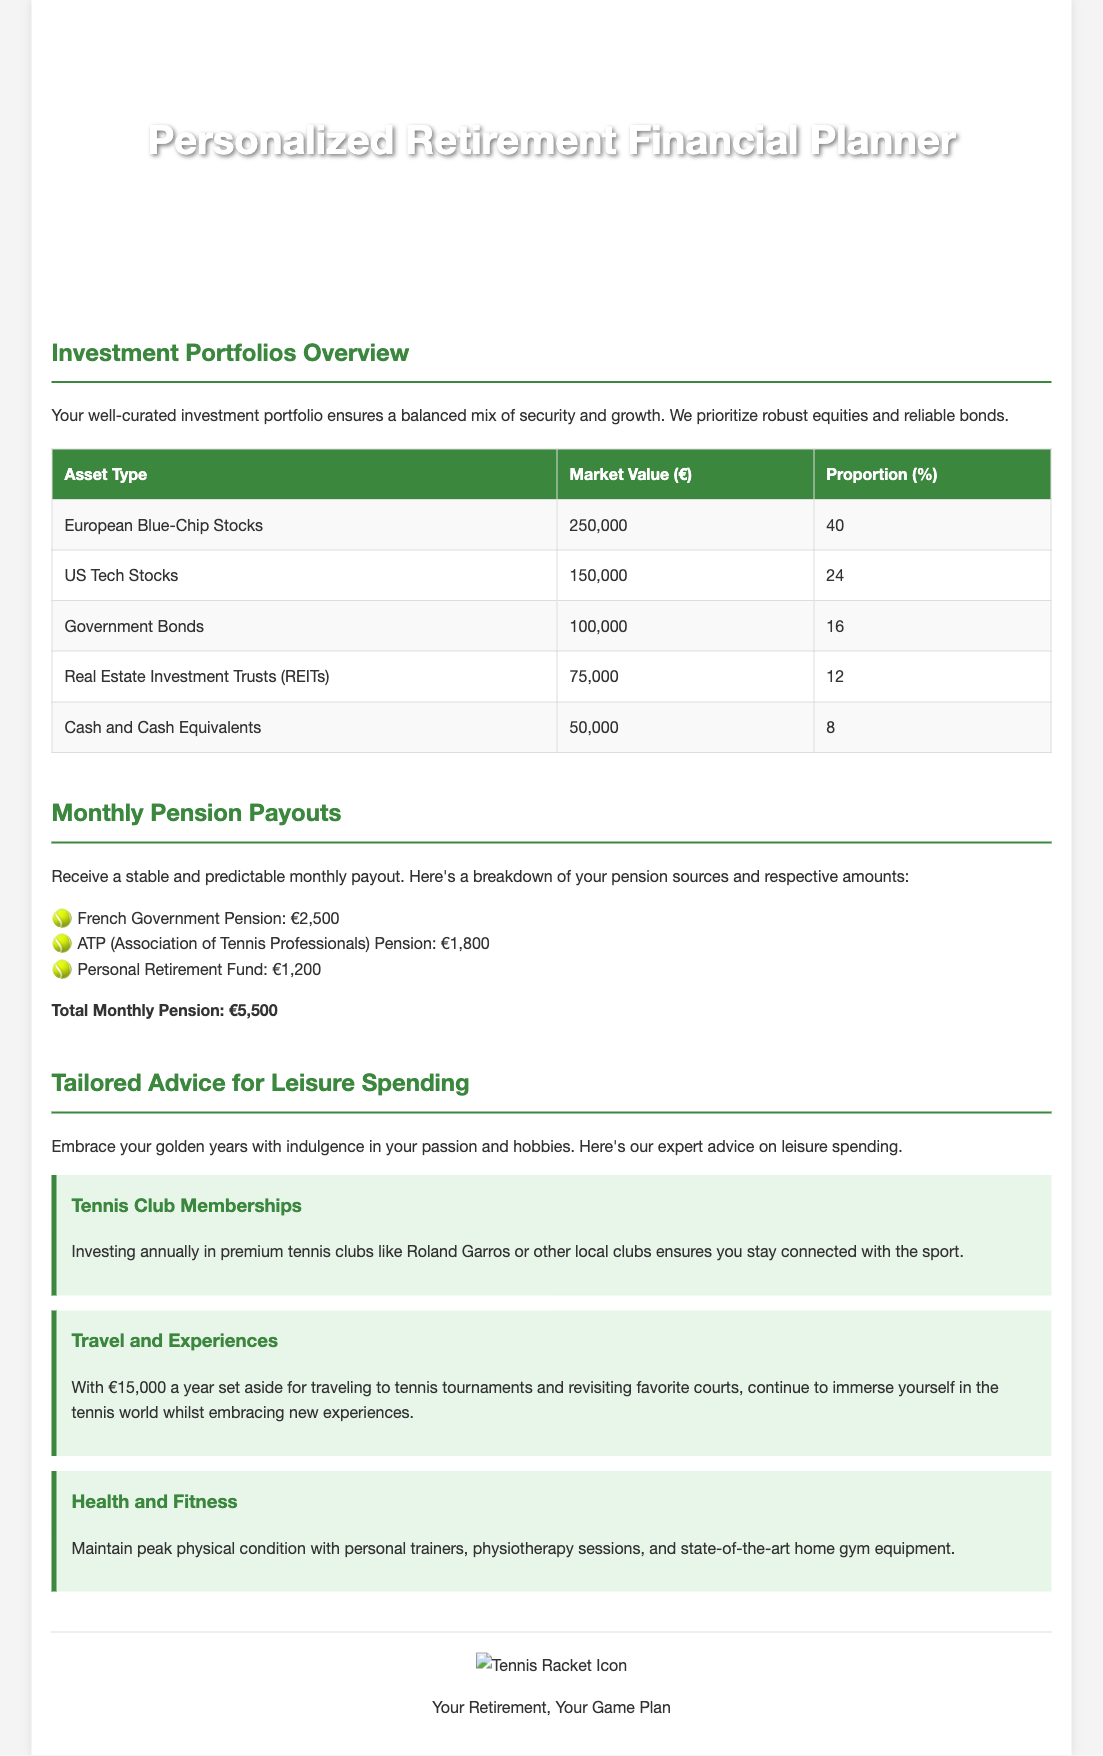what is the title of the document? The title provides an overview of the document's purpose, specifically designed for retired professional French tennis players.
Answer: Personalized Retirement Financial Planner for Retired Professional French Tennis Player how much is the total monthly pension? The total monthly pension is a sum calculated from individual pension sources listed in the document.
Answer: €5,500 what is the market value of European Blue-Chip Stocks? The market value of European Blue-Chip Stocks is specified in the investment portfolios overview table.
Answer: €250,000 which type of advice is given for leisure spending? The document provides tailored advice in three specific areas related to leisure spending.
Answer: Tennis Club Memberships, Travel and Experiences, Health and Fitness what percentage of the portfolio is allocated to Government Bonds? This percentage is listed in the investment portfolios overview section of the document.
Answer: 16 how much is allocated annually for travel? The annual allocation for travel is mentioned in the tailored advice for leisure spending section.
Answer: €15,000 what type of financial products are prioritized in the investment portfolio? This information summarizes the growth and security focus of the investment portfolio.
Answer: Robust equities and reliable bonds what is the background image in the header? The background image description indicates the document's tennis theme and engagement with the sport.
Answer: tennis_court_background.jpg 